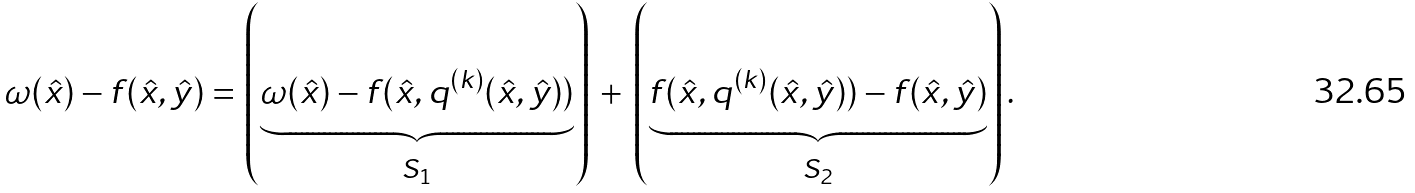Convert formula to latex. <formula><loc_0><loc_0><loc_500><loc_500>\omega ( \hat { x } ) - f ( \hat { x } , \hat { y } ) = \left ( \underbrace { \omega ( \hat { x } ) - f ( \hat { x } , q ^ { ( k ) } ( \hat { x } , \hat { y } ) ) } _ { S _ { 1 } } \right ) \, + \, \left ( \underbrace { f ( \hat { x } , q ^ { ( k ) } ( \hat { x } , \hat { y } ) ) - f ( \hat { x } , \hat { y } ) } _ { S _ { 2 } } \right ) .</formula> 